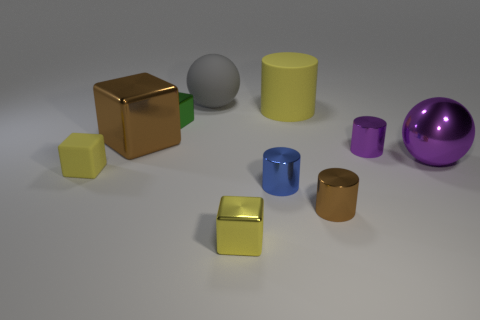Are there any patterns or logos on any of the objects? No, there are no patterns or logos visible on any of the objects. They all have solid, uniform colors. 